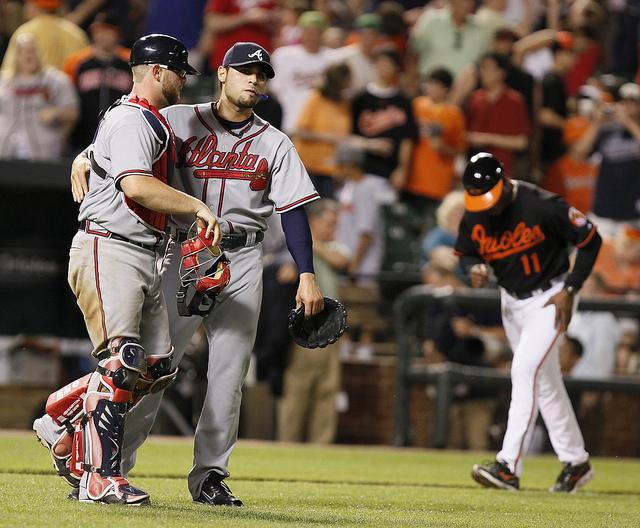What are the two men close to each other about to do?
Keep it brief. Hug. What is the color of the uniforms?
Keep it brief. Gray and black. Are the players of the same team?
Short answer required. No. Are the people in the crowd standing?
Give a very brief answer. Yes. 